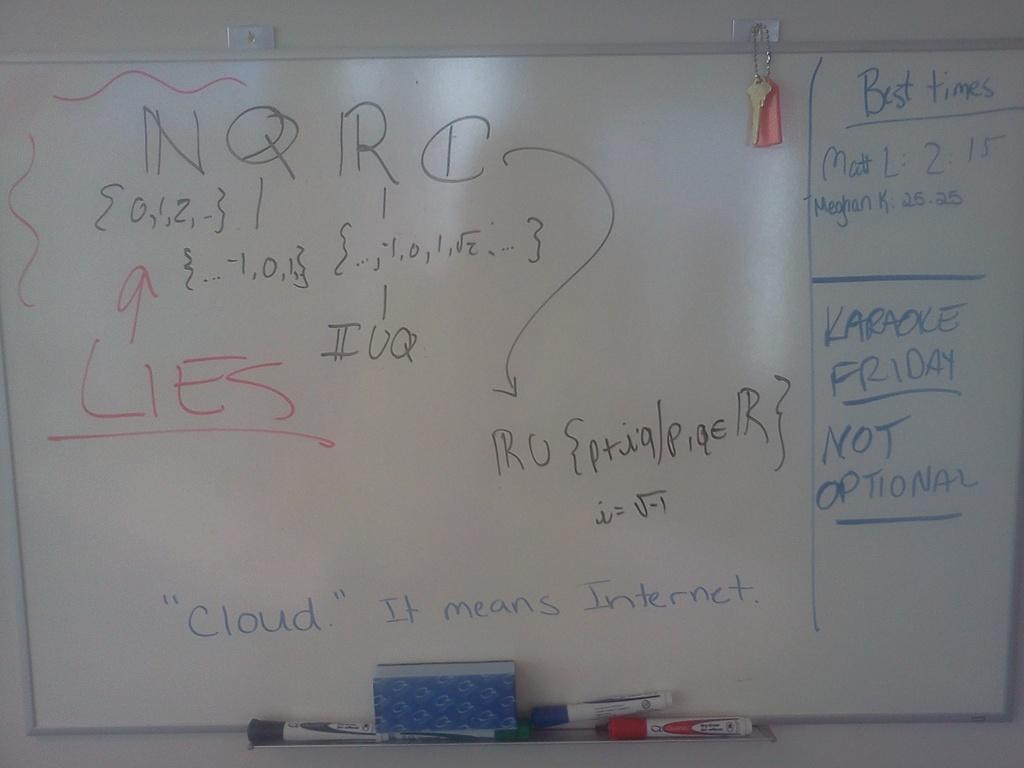<image>
Describe the image concisely. Dry erase whiteboard with best times written in the top right corner 